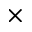Convert formula to latex. <formula><loc_0><loc_0><loc_500><loc_500>\times</formula> 